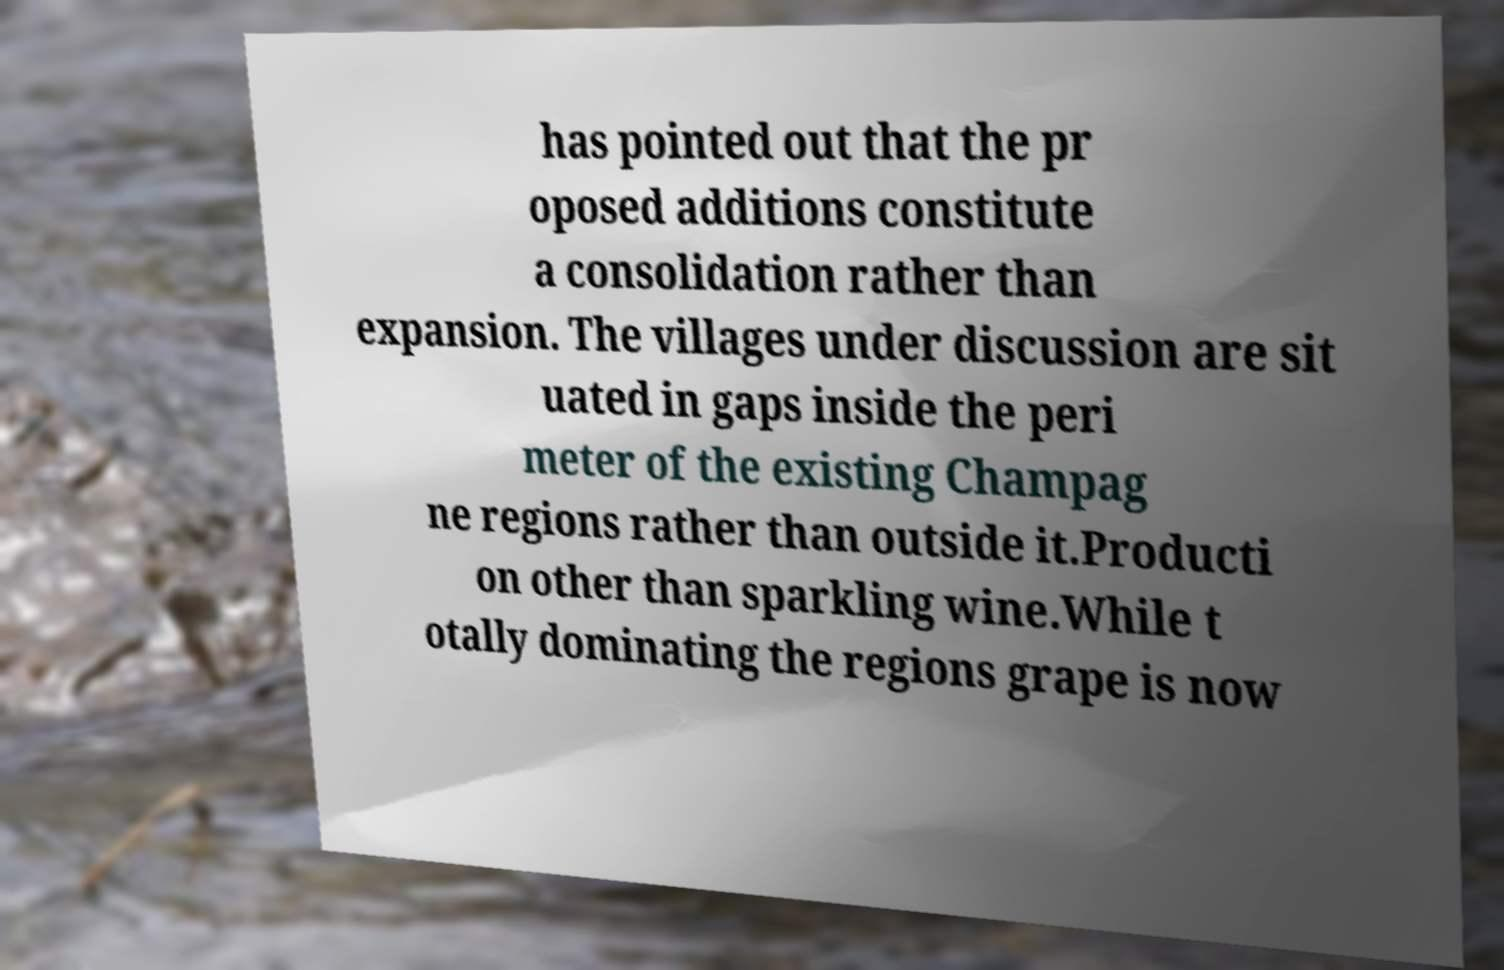What messages or text are displayed in this image? I need them in a readable, typed format. has pointed out that the pr oposed additions constitute a consolidation rather than expansion. The villages under discussion are sit uated in gaps inside the peri meter of the existing Champag ne regions rather than outside it.Producti on other than sparkling wine.While t otally dominating the regions grape is now 